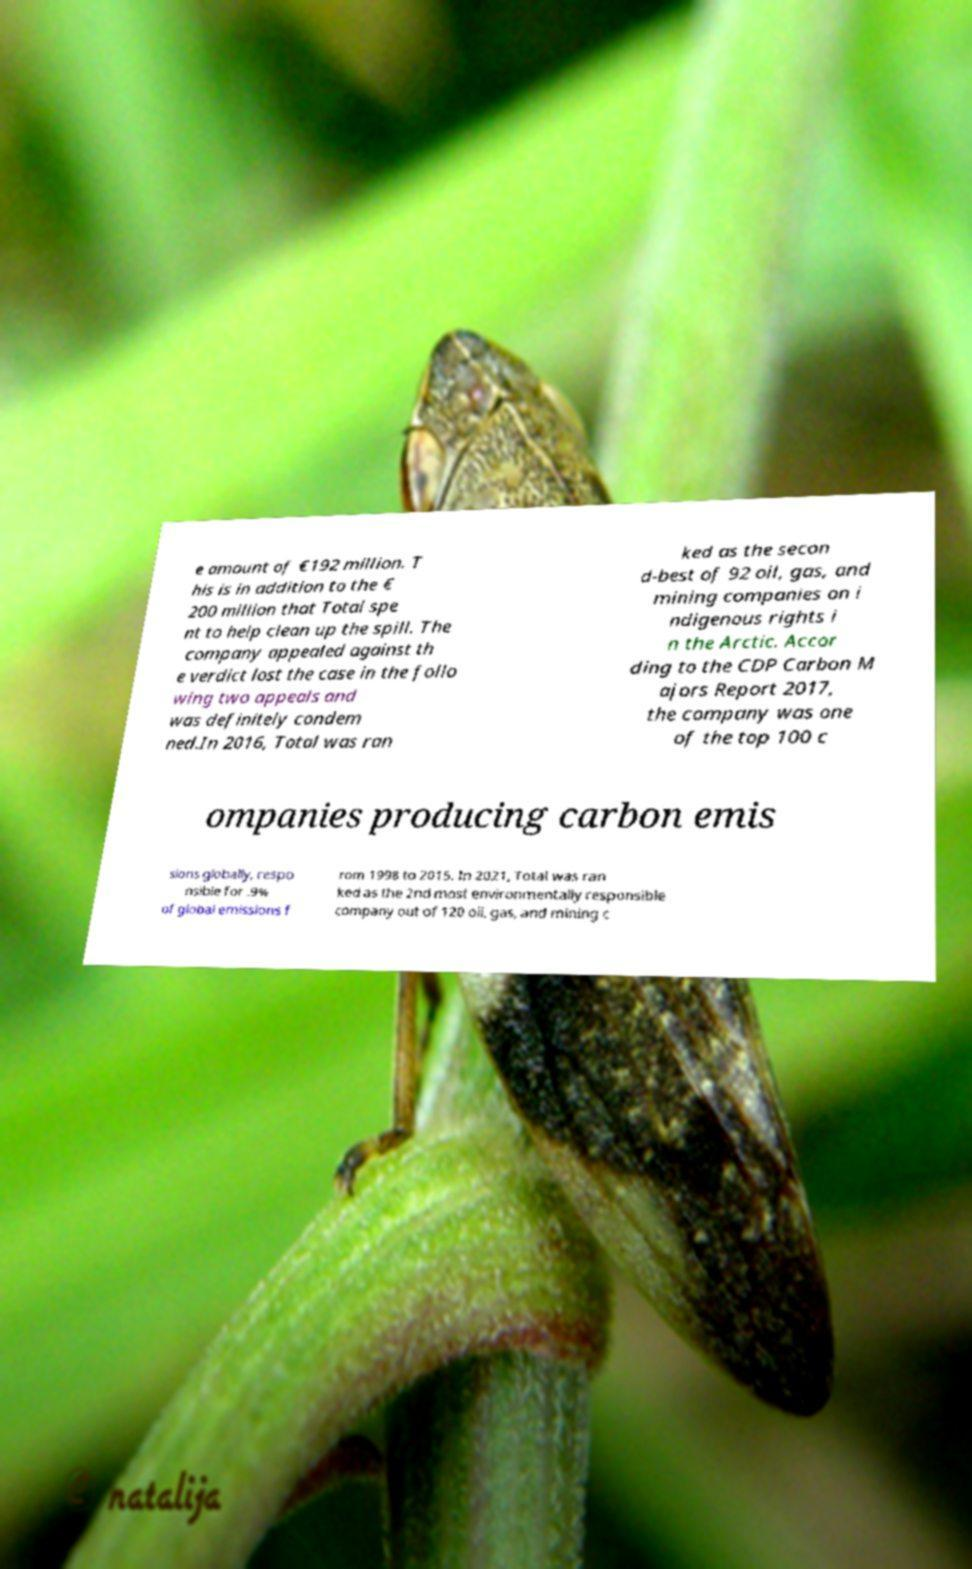I need the written content from this picture converted into text. Can you do that? e amount of €192 million. T his is in addition to the € 200 million that Total spe nt to help clean up the spill. The company appealed against th e verdict lost the case in the follo wing two appeals and was definitely condem ned.In 2016, Total was ran ked as the secon d-best of 92 oil, gas, and mining companies on i ndigenous rights i n the Arctic. Accor ding to the CDP Carbon M ajors Report 2017, the company was one of the top 100 c ompanies producing carbon emis sions globally, respo nsible for .9% of global emissions f rom 1998 to 2015. In 2021, Total was ran ked as the 2nd most environmentally responsible company out of 120 oil, gas, and mining c 